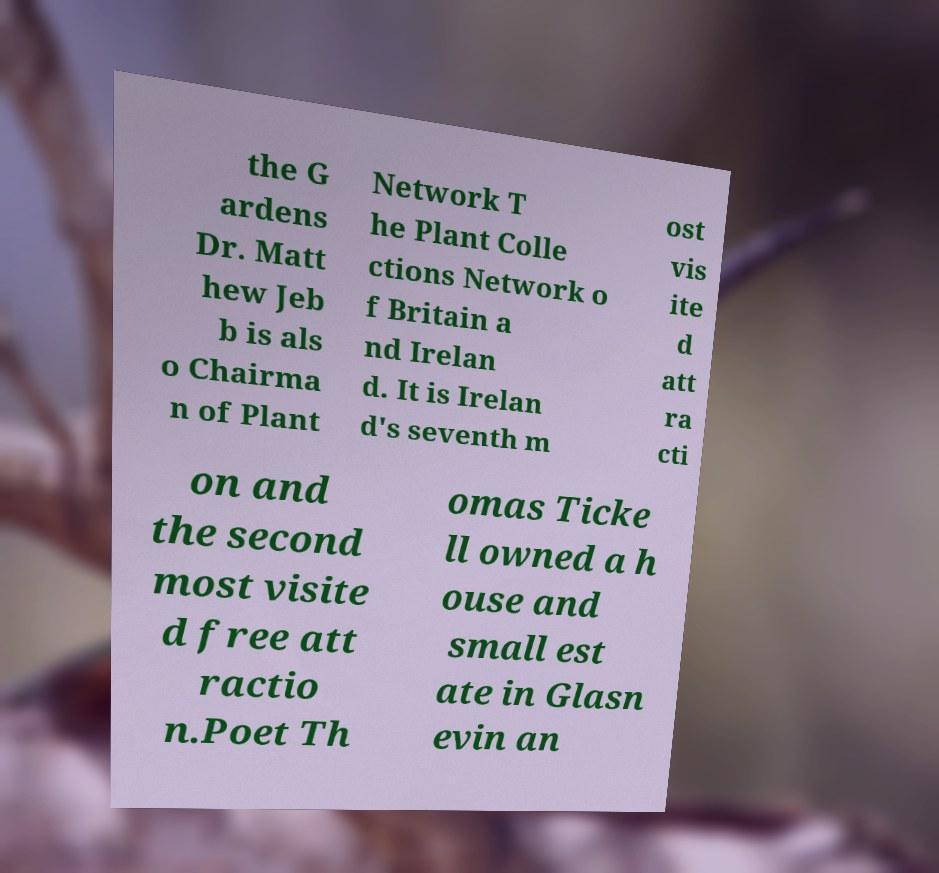For documentation purposes, I need the text within this image transcribed. Could you provide that? the G ardens Dr. Matt hew Jeb b is als o Chairma n of Plant Network T he Plant Colle ctions Network o f Britain a nd Irelan d. It is Irelan d's seventh m ost vis ite d att ra cti on and the second most visite d free att ractio n.Poet Th omas Ticke ll owned a h ouse and small est ate in Glasn evin an 